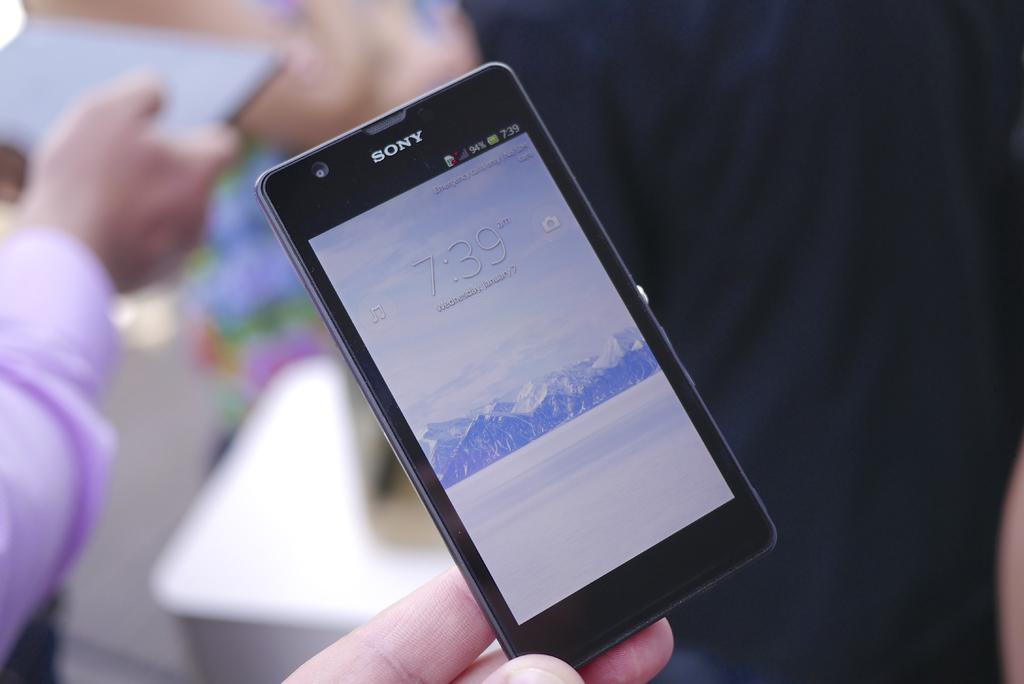Provide a one-sentence caption for the provided image. A black Sony device shows the time of 7:39. 